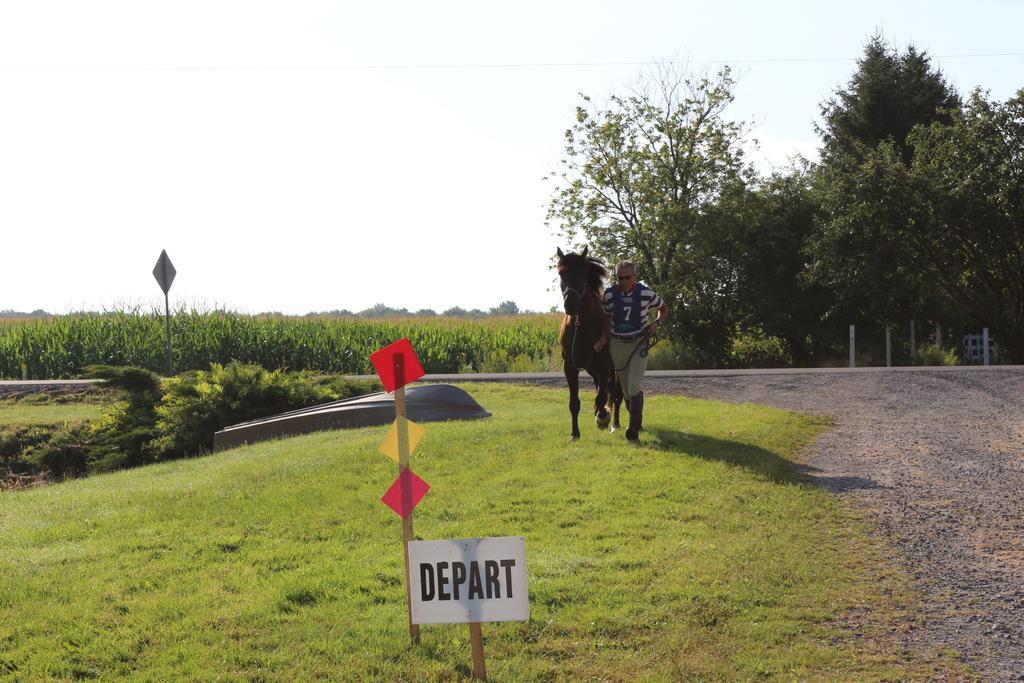Please provide a concise description of this image. In this image we can see a horse and a man. In the background, we can see plants, trees and fence. At the top of the image, we can see the sky. There is a board and pole on the left side of the image. At the bottom of the image, we can see the boards. 